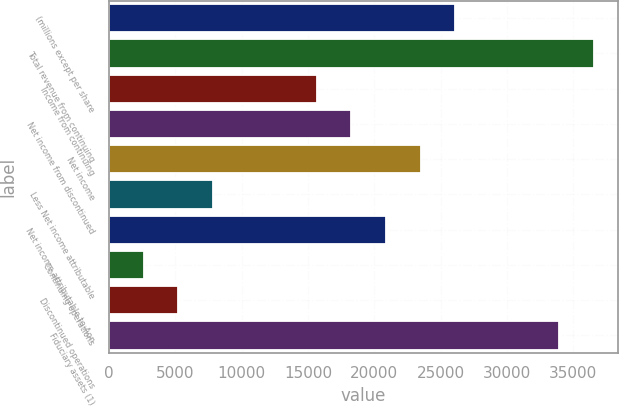Convert chart. <chart><loc_0><loc_0><loc_500><loc_500><bar_chart><fcel>(millions except per share<fcel>Total revenue from continuing<fcel>Income from continuing<fcel>Net income from discontinued<fcel>Net income<fcel>Less Net income attributable<fcel>Net income attributable to Aon<fcel>Continuing operations<fcel>Discontinued operations<fcel>Fiduciary assets (1)<nl><fcel>26088<fcel>36522.7<fcel>15653.4<fcel>18262<fcel>23479.3<fcel>7827.39<fcel>20870.7<fcel>2610.07<fcel>5218.73<fcel>33914<nl></chart> 